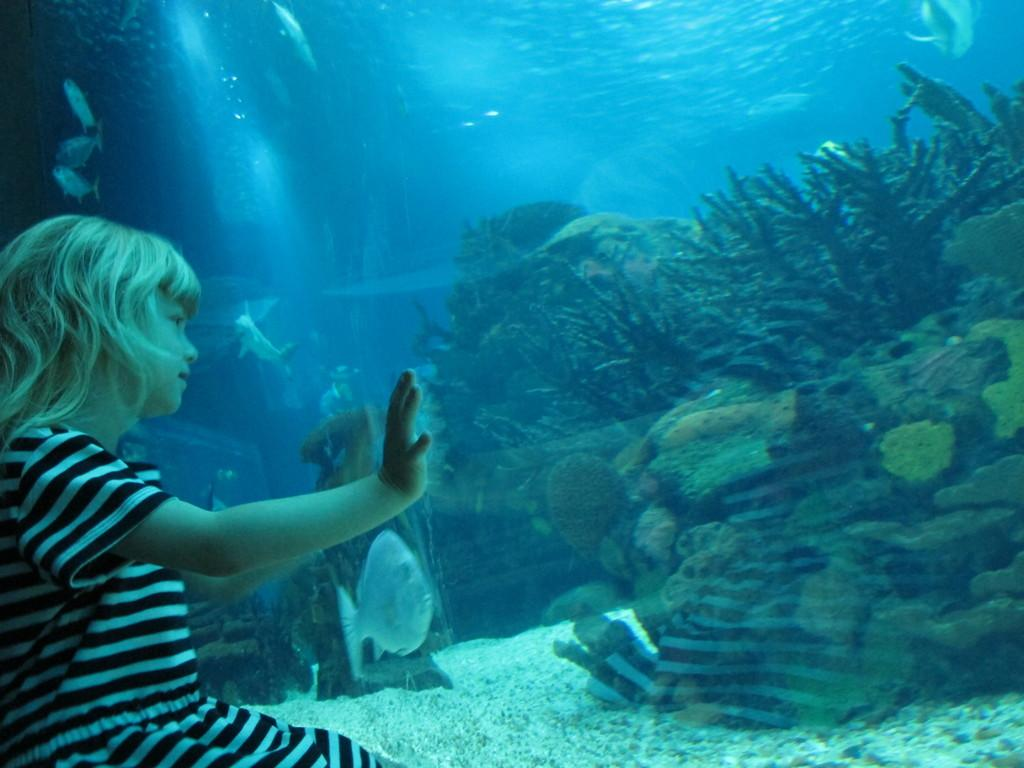Who is on the left side of the image? There is a girl on the left side of the image. What is in front of the girl? There is an aquarium in front of the girl. What can be seen inside the aquarium? There are fishes in the aquarium. What type of vegetation is visible in the image? Water plants are visible in the image. How many chairs are visible in the image? There are no chairs present in the image. Can you see a rat in the image? There is no rat present in the image. 